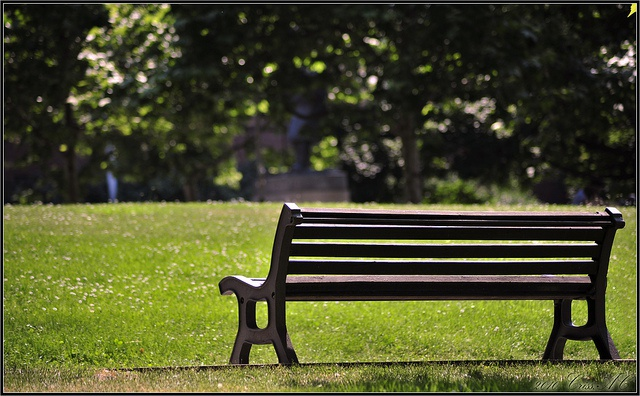Describe the objects in this image and their specific colors. I can see a bench in gray, black, lavender, and darkgray tones in this image. 